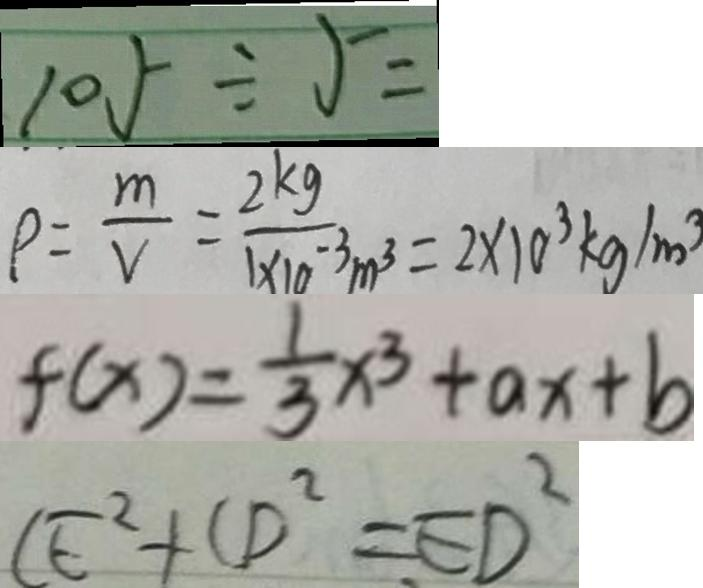<formula> <loc_0><loc_0><loc_500><loc_500>1 0 5 \div 5 = 
 \rho = \frac { m } { v } = \frac { 2 k g } { 1 \times 1 0 ^ { - 3 } m ^ { 3 } } = 2 \times 1 0 ^ { 3 } k g / m ^ { 3 } 
 f ( x ) = \frac { 1 } { 3 } x ^ { 3 } + a x + b 
 C E ^ { 2 } + C D ^ { 2 } = E D ^ { 2 }</formula> 